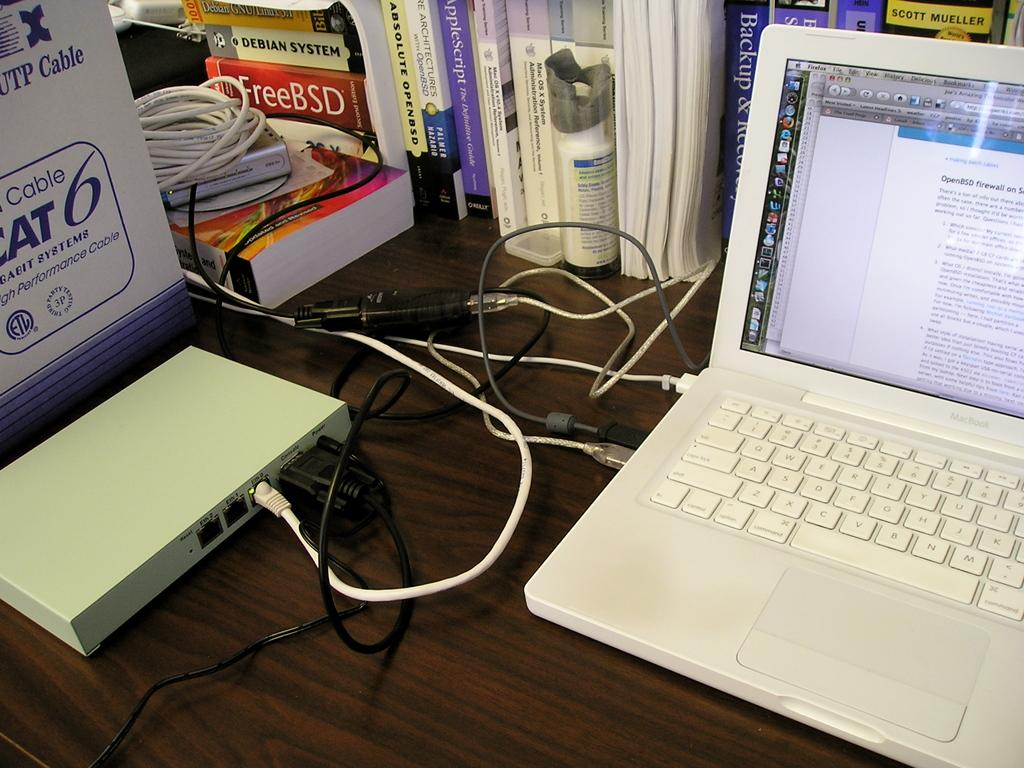What is the main piece of furniture in the image? There is a table in the image. What items can be seen on the table? There are books and a system (likely a computer or laptop) on the table. What type of connector is present on the table? There is a cable connector on the table. How many ladybugs can be seen crawling on the books in the image? There are no ladybugs present in the image; it only features books, a system, and a cable connector on the table. 